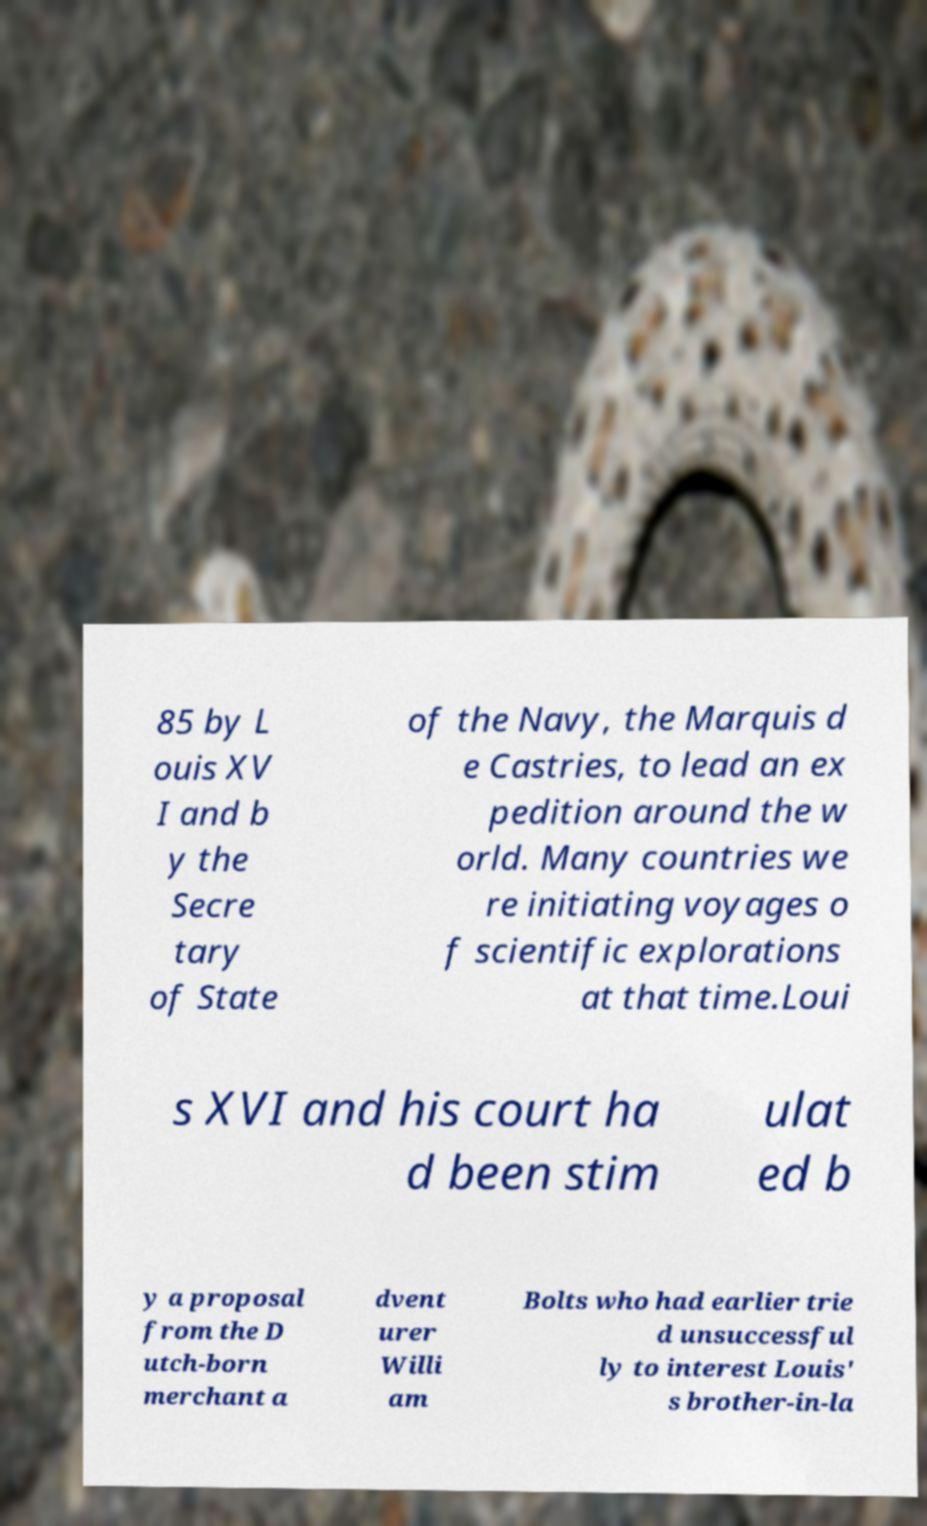Please read and relay the text visible in this image. What does it say? 85 by L ouis XV I and b y the Secre tary of State of the Navy, the Marquis d e Castries, to lead an ex pedition around the w orld. Many countries we re initiating voyages o f scientific explorations at that time.Loui s XVI and his court ha d been stim ulat ed b y a proposal from the D utch-born merchant a dvent urer Willi am Bolts who had earlier trie d unsuccessful ly to interest Louis' s brother-in-la 